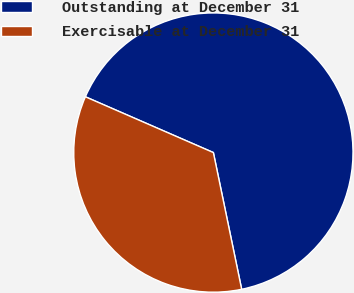Convert chart. <chart><loc_0><loc_0><loc_500><loc_500><pie_chart><fcel>Outstanding at December 31<fcel>Exercisable at December 31<nl><fcel>65.21%<fcel>34.79%<nl></chart> 